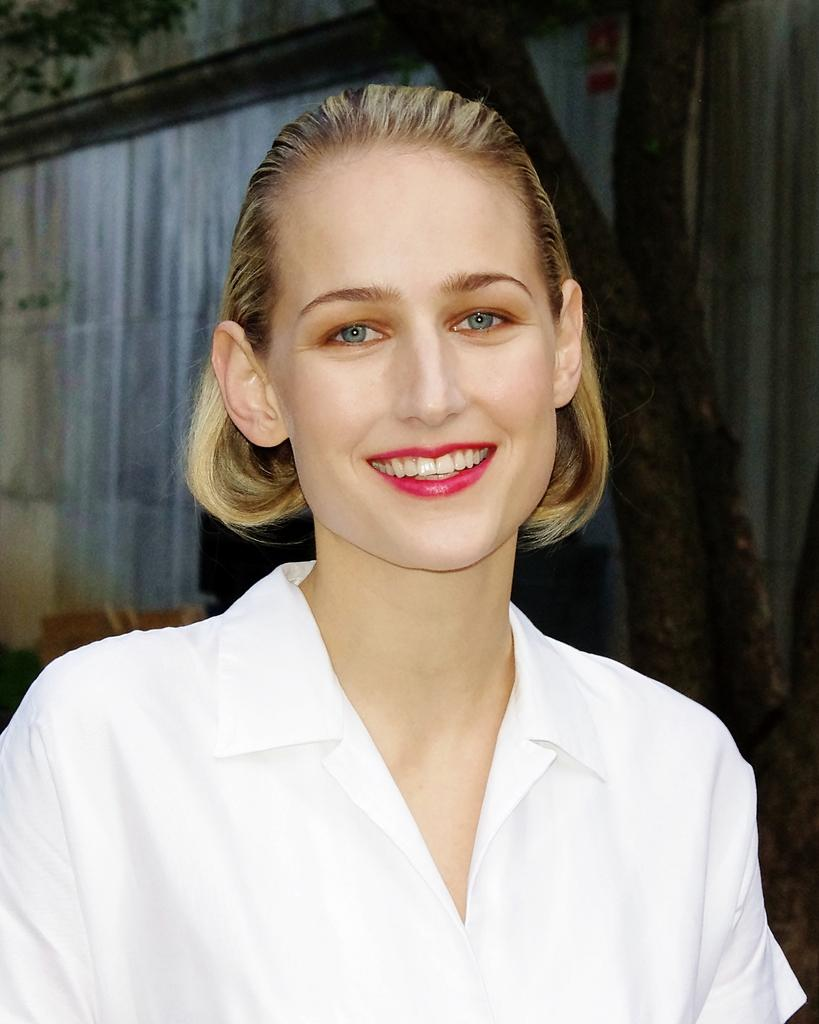What is present in the image? There is a person in the image. Can you describe the person's attire? The person is wearing clothes. What else can be seen in the image besides the person? There is a stem in front of a wall in the image. What type of mark is visible on the person's account in the image? There is no mention of a mark or an account in the image, so this question cannot be answered definitively. 